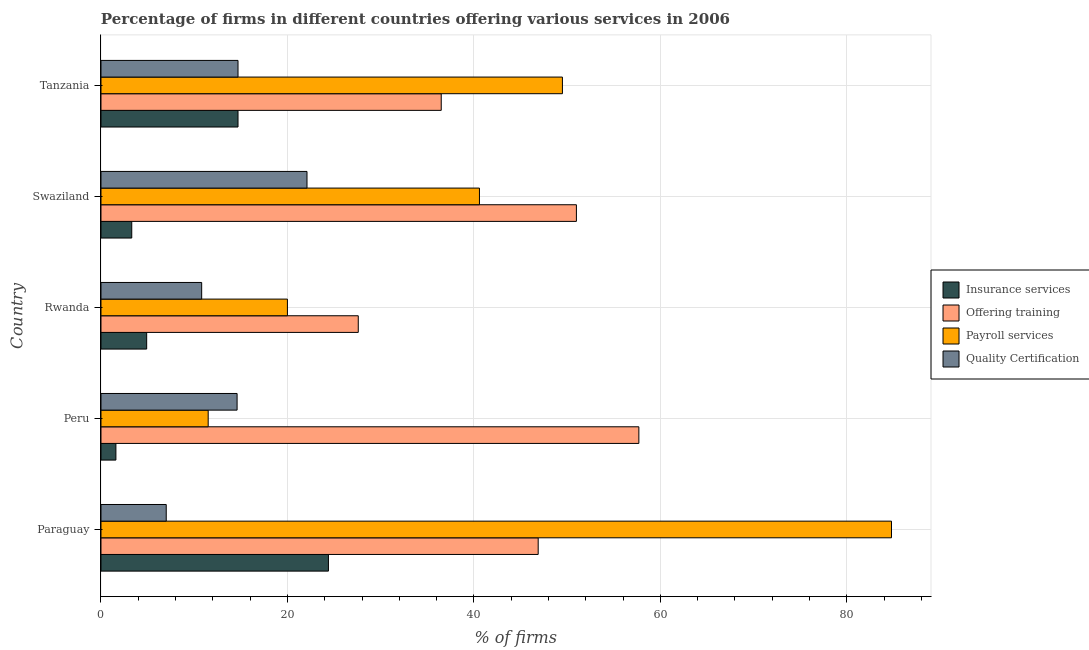How many different coloured bars are there?
Your answer should be compact. 4. Are the number of bars on each tick of the Y-axis equal?
Make the answer very short. Yes. How many bars are there on the 3rd tick from the top?
Give a very brief answer. 4. What is the label of the 3rd group of bars from the top?
Your response must be concise. Rwanda. In how many cases, is the number of bars for a given country not equal to the number of legend labels?
Make the answer very short. 0. What is the percentage of firms offering quality certification in Swaziland?
Make the answer very short. 22.1. Across all countries, what is the maximum percentage of firms offering quality certification?
Your response must be concise. 22.1. Across all countries, what is the minimum percentage of firms offering training?
Ensure brevity in your answer.  27.6. In which country was the percentage of firms offering quality certification maximum?
Provide a short and direct response. Swaziland. In which country was the percentage of firms offering training minimum?
Provide a short and direct response. Rwanda. What is the total percentage of firms offering payroll services in the graph?
Offer a very short reply. 206.4. What is the difference between the percentage of firms offering payroll services in Tanzania and the percentage of firms offering insurance services in Peru?
Offer a terse response. 47.9. What is the average percentage of firms offering training per country?
Provide a short and direct response. 43.94. What is the difference between the percentage of firms offering insurance services and percentage of firms offering payroll services in Tanzania?
Your answer should be very brief. -34.8. What is the ratio of the percentage of firms offering insurance services in Peru to that in Swaziland?
Your answer should be very brief. 0.48. What is the difference between the highest and the second highest percentage of firms offering payroll services?
Make the answer very short. 35.3. What is the difference between the highest and the lowest percentage of firms offering training?
Offer a terse response. 30.1. What does the 2nd bar from the top in Rwanda represents?
Make the answer very short. Payroll services. What does the 4th bar from the bottom in Rwanda represents?
Your answer should be compact. Quality Certification. Are all the bars in the graph horizontal?
Offer a terse response. Yes. How many countries are there in the graph?
Your answer should be very brief. 5. Are the values on the major ticks of X-axis written in scientific E-notation?
Offer a very short reply. No. Does the graph contain grids?
Offer a terse response. Yes. How many legend labels are there?
Make the answer very short. 4. What is the title of the graph?
Offer a terse response. Percentage of firms in different countries offering various services in 2006. What is the label or title of the X-axis?
Provide a succinct answer. % of firms. What is the label or title of the Y-axis?
Offer a terse response. Country. What is the % of firms of Insurance services in Paraguay?
Provide a succinct answer. 24.4. What is the % of firms of Offering training in Paraguay?
Keep it short and to the point. 46.9. What is the % of firms in Payroll services in Paraguay?
Provide a succinct answer. 84.8. What is the % of firms in Quality Certification in Paraguay?
Provide a succinct answer. 7. What is the % of firms of Offering training in Peru?
Provide a succinct answer. 57.7. What is the % of firms of Quality Certification in Peru?
Keep it short and to the point. 14.6. What is the % of firms in Offering training in Rwanda?
Offer a terse response. 27.6. What is the % of firms of Insurance services in Swaziland?
Your answer should be very brief. 3.3. What is the % of firms of Offering training in Swaziland?
Provide a succinct answer. 51. What is the % of firms of Payroll services in Swaziland?
Provide a short and direct response. 40.6. What is the % of firms of Quality Certification in Swaziland?
Make the answer very short. 22.1. What is the % of firms of Offering training in Tanzania?
Give a very brief answer. 36.5. What is the % of firms in Payroll services in Tanzania?
Your answer should be compact. 49.5. What is the % of firms in Quality Certification in Tanzania?
Keep it short and to the point. 14.7. Across all countries, what is the maximum % of firms of Insurance services?
Provide a short and direct response. 24.4. Across all countries, what is the maximum % of firms of Offering training?
Keep it short and to the point. 57.7. Across all countries, what is the maximum % of firms of Payroll services?
Your answer should be very brief. 84.8. Across all countries, what is the maximum % of firms of Quality Certification?
Your answer should be compact. 22.1. Across all countries, what is the minimum % of firms in Offering training?
Your answer should be compact. 27.6. Across all countries, what is the minimum % of firms in Payroll services?
Keep it short and to the point. 11.5. What is the total % of firms in Insurance services in the graph?
Offer a very short reply. 48.9. What is the total % of firms in Offering training in the graph?
Your answer should be very brief. 219.7. What is the total % of firms of Payroll services in the graph?
Provide a succinct answer. 206.4. What is the total % of firms of Quality Certification in the graph?
Your response must be concise. 69.2. What is the difference between the % of firms in Insurance services in Paraguay and that in Peru?
Provide a short and direct response. 22.8. What is the difference between the % of firms of Payroll services in Paraguay and that in Peru?
Keep it short and to the point. 73.3. What is the difference between the % of firms of Insurance services in Paraguay and that in Rwanda?
Your response must be concise. 19.5. What is the difference between the % of firms in Offering training in Paraguay and that in Rwanda?
Make the answer very short. 19.3. What is the difference between the % of firms of Payroll services in Paraguay and that in Rwanda?
Offer a very short reply. 64.8. What is the difference between the % of firms of Quality Certification in Paraguay and that in Rwanda?
Provide a succinct answer. -3.8. What is the difference between the % of firms of Insurance services in Paraguay and that in Swaziland?
Offer a terse response. 21.1. What is the difference between the % of firms in Payroll services in Paraguay and that in Swaziland?
Give a very brief answer. 44.2. What is the difference between the % of firms in Quality Certification in Paraguay and that in Swaziland?
Offer a very short reply. -15.1. What is the difference between the % of firms of Insurance services in Paraguay and that in Tanzania?
Your response must be concise. 9.7. What is the difference between the % of firms in Payroll services in Paraguay and that in Tanzania?
Offer a terse response. 35.3. What is the difference between the % of firms in Insurance services in Peru and that in Rwanda?
Provide a succinct answer. -3.3. What is the difference between the % of firms in Offering training in Peru and that in Rwanda?
Your answer should be very brief. 30.1. What is the difference between the % of firms in Quality Certification in Peru and that in Rwanda?
Make the answer very short. 3.8. What is the difference between the % of firms in Payroll services in Peru and that in Swaziland?
Provide a succinct answer. -29.1. What is the difference between the % of firms of Quality Certification in Peru and that in Swaziland?
Provide a short and direct response. -7.5. What is the difference between the % of firms in Insurance services in Peru and that in Tanzania?
Offer a very short reply. -13.1. What is the difference between the % of firms of Offering training in Peru and that in Tanzania?
Provide a succinct answer. 21.2. What is the difference between the % of firms in Payroll services in Peru and that in Tanzania?
Make the answer very short. -38. What is the difference between the % of firms of Insurance services in Rwanda and that in Swaziland?
Ensure brevity in your answer.  1.6. What is the difference between the % of firms in Offering training in Rwanda and that in Swaziland?
Keep it short and to the point. -23.4. What is the difference between the % of firms in Payroll services in Rwanda and that in Swaziland?
Make the answer very short. -20.6. What is the difference between the % of firms of Payroll services in Rwanda and that in Tanzania?
Provide a succinct answer. -29.5. What is the difference between the % of firms in Insurance services in Paraguay and the % of firms in Offering training in Peru?
Your answer should be compact. -33.3. What is the difference between the % of firms in Insurance services in Paraguay and the % of firms in Payroll services in Peru?
Your answer should be very brief. 12.9. What is the difference between the % of firms in Insurance services in Paraguay and the % of firms in Quality Certification in Peru?
Keep it short and to the point. 9.8. What is the difference between the % of firms in Offering training in Paraguay and the % of firms in Payroll services in Peru?
Keep it short and to the point. 35.4. What is the difference between the % of firms of Offering training in Paraguay and the % of firms of Quality Certification in Peru?
Ensure brevity in your answer.  32.3. What is the difference between the % of firms of Payroll services in Paraguay and the % of firms of Quality Certification in Peru?
Your answer should be compact. 70.2. What is the difference between the % of firms of Insurance services in Paraguay and the % of firms of Payroll services in Rwanda?
Provide a short and direct response. 4.4. What is the difference between the % of firms of Insurance services in Paraguay and the % of firms of Quality Certification in Rwanda?
Your response must be concise. 13.6. What is the difference between the % of firms in Offering training in Paraguay and the % of firms in Payroll services in Rwanda?
Make the answer very short. 26.9. What is the difference between the % of firms of Offering training in Paraguay and the % of firms of Quality Certification in Rwanda?
Give a very brief answer. 36.1. What is the difference between the % of firms of Insurance services in Paraguay and the % of firms of Offering training in Swaziland?
Ensure brevity in your answer.  -26.6. What is the difference between the % of firms in Insurance services in Paraguay and the % of firms in Payroll services in Swaziland?
Make the answer very short. -16.2. What is the difference between the % of firms in Insurance services in Paraguay and the % of firms in Quality Certification in Swaziland?
Keep it short and to the point. 2.3. What is the difference between the % of firms of Offering training in Paraguay and the % of firms of Quality Certification in Swaziland?
Your answer should be compact. 24.8. What is the difference between the % of firms in Payroll services in Paraguay and the % of firms in Quality Certification in Swaziland?
Offer a terse response. 62.7. What is the difference between the % of firms of Insurance services in Paraguay and the % of firms of Payroll services in Tanzania?
Ensure brevity in your answer.  -25.1. What is the difference between the % of firms in Offering training in Paraguay and the % of firms in Payroll services in Tanzania?
Ensure brevity in your answer.  -2.6. What is the difference between the % of firms of Offering training in Paraguay and the % of firms of Quality Certification in Tanzania?
Ensure brevity in your answer.  32.2. What is the difference between the % of firms in Payroll services in Paraguay and the % of firms in Quality Certification in Tanzania?
Give a very brief answer. 70.1. What is the difference between the % of firms in Insurance services in Peru and the % of firms in Payroll services in Rwanda?
Offer a very short reply. -18.4. What is the difference between the % of firms in Insurance services in Peru and the % of firms in Quality Certification in Rwanda?
Provide a succinct answer. -9.2. What is the difference between the % of firms of Offering training in Peru and the % of firms of Payroll services in Rwanda?
Give a very brief answer. 37.7. What is the difference between the % of firms in Offering training in Peru and the % of firms in Quality Certification in Rwanda?
Your answer should be very brief. 46.9. What is the difference between the % of firms of Payroll services in Peru and the % of firms of Quality Certification in Rwanda?
Provide a short and direct response. 0.7. What is the difference between the % of firms in Insurance services in Peru and the % of firms in Offering training in Swaziland?
Ensure brevity in your answer.  -49.4. What is the difference between the % of firms in Insurance services in Peru and the % of firms in Payroll services in Swaziland?
Your response must be concise. -39. What is the difference between the % of firms in Insurance services in Peru and the % of firms in Quality Certification in Swaziland?
Give a very brief answer. -20.5. What is the difference between the % of firms of Offering training in Peru and the % of firms of Quality Certification in Swaziland?
Offer a very short reply. 35.6. What is the difference between the % of firms of Insurance services in Peru and the % of firms of Offering training in Tanzania?
Provide a succinct answer. -34.9. What is the difference between the % of firms in Insurance services in Peru and the % of firms in Payroll services in Tanzania?
Provide a succinct answer. -47.9. What is the difference between the % of firms of Offering training in Peru and the % of firms of Payroll services in Tanzania?
Provide a succinct answer. 8.2. What is the difference between the % of firms in Offering training in Peru and the % of firms in Quality Certification in Tanzania?
Provide a short and direct response. 43. What is the difference between the % of firms in Payroll services in Peru and the % of firms in Quality Certification in Tanzania?
Give a very brief answer. -3.2. What is the difference between the % of firms in Insurance services in Rwanda and the % of firms in Offering training in Swaziland?
Give a very brief answer. -46.1. What is the difference between the % of firms in Insurance services in Rwanda and the % of firms in Payroll services in Swaziland?
Your response must be concise. -35.7. What is the difference between the % of firms of Insurance services in Rwanda and the % of firms of Quality Certification in Swaziland?
Your response must be concise. -17.2. What is the difference between the % of firms in Offering training in Rwanda and the % of firms in Payroll services in Swaziland?
Provide a succinct answer. -13. What is the difference between the % of firms in Payroll services in Rwanda and the % of firms in Quality Certification in Swaziland?
Provide a short and direct response. -2.1. What is the difference between the % of firms of Insurance services in Rwanda and the % of firms of Offering training in Tanzania?
Provide a short and direct response. -31.6. What is the difference between the % of firms of Insurance services in Rwanda and the % of firms of Payroll services in Tanzania?
Offer a terse response. -44.6. What is the difference between the % of firms in Offering training in Rwanda and the % of firms in Payroll services in Tanzania?
Provide a short and direct response. -21.9. What is the difference between the % of firms of Payroll services in Rwanda and the % of firms of Quality Certification in Tanzania?
Provide a short and direct response. 5.3. What is the difference between the % of firms of Insurance services in Swaziland and the % of firms of Offering training in Tanzania?
Offer a terse response. -33.2. What is the difference between the % of firms of Insurance services in Swaziland and the % of firms of Payroll services in Tanzania?
Keep it short and to the point. -46.2. What is the difference between the % of firms of Insurance services in Swaziland and the % of firms of Quality Certification in Tanzania?
Keep it short and to the point. -11.4. What is the difference between the % of firms of Offering training in Swaziland and the % of firms of Quality Certification in Tanzania?
Your response must be concise. 36.3. What is the difference between the % of firms in Payroll services in Swaziland and the % of firms in Quality Certification in Tanzania?
Offer a very short reply. 25.9. What is the average % of firms in Insurance services per country?
Offer a very short reply. 9.78. What is the average % of firms of Offering training per country?
Your answer should be very brief. 43.94. What is the average % of firms of Payroll services per country?
Your answer should be very brief. 41.28. What is the average % of firms in Quality Certification per country?
Keep it short and to the point. 13.84. What is the difference between the % of firms of Insurance services and % of firms of Offering training in Paraguay?
Offer a terse response. -22.5. What is the difference between the % of firms of Insurance services and % of firms of Payroll services in Paraguay?
Offer a very short reply. -60.4. What is the difference between the % of firms of Offering training and % of firms of Payroll services in Paraguay?
Your answer should be compact. -37.9. What is the difference between the % of firms in Offering training and % of firms in Quality Certification in Paraguay?
Provide a succinct answer. 39.9. What is the difference between the % of firms of Payroll services and % of firms of Quality Certification in Paraguay?
Offer a very short reply. 77.8. What is the difference between the % of firms in Insurance services and % of firms in Offering training in Peru?
Give a very brief answer. -56.1. What is the difference between the % of firms of Insurance services and % of firms of Payroll services in Peru?
Your answer should be very brief. -9.9. What is the difference between the % of firms in Insurance services and % of firms in Quality Certification in Peru?
Give a very brief answer. -13. What is the difference between the % of firms of Offering training and % of firms of Payroll services in Peru?
Make the answer very short. 46.2. What is the difference between the % of firms in Offering training and % of firms in Quality Certification in Peru?
Offer a very short reply. 43.1. What is the difference between the % of firms in Payroll services and % of firms in Quality Certification in Peru?
Your answer should be compact. -3.1. What is the difference between the % of firms in Insurance services and % of firms in Offering training in Rwanda?
Your answer should be very brief. -22.7. What is the difference between the % of firms of Insurance services and % of firms of Payroll services in Rwanda?
Provide a short and direct response. -15.1. What is the difference between the % of firms in Offering training and % of firms in Payroll services in Rwanda?
Give a very brief answer. 7.6. What is the difference between the % of firms of Offering training and % of firms of Quality Certification in Rwanda?
Provide a succinct answer. 16.8. What is the difference between the % of firms of Payroll services and % of firms of Quality Certification in Rwanda?
Provide a succinct answer. 9.2. What is the difference between the % of firms of Insurance services and % of firms of Offering training in Swaziland?
Your answer should be very brief. -47.7. What is the difference between the % of firms in Insurance services and % of firms in Payroll services in Swaziland?
Offer a very short reply. -37.3. What is the difference between the % of firms in Insurance services and % of firms in Quality Certification in Swaziland?
Offer a terse response. -18.8. What is the difference between the % of firms in Offering training and % of firms in Payroll services in Swaziland?
Give a very brief answer. 10.4. What is the difference between the % of firms in Offering training and % of firms in Quality Certification in Swaziland?
Offer a very short reply. 28.9. What is the difference between the % of firms in Payroll services and % of firms in Quality Certification in Swaziland?
Give a very brief answer. 18.5. What is the difference between the % of firms in Insurance services and % of firms in Offering training in Tanzania?
Your response must be concise. -21.8. What is the difference between the % of firms in Insurance services and % of firms in Payroll services in Tanzania?
Ensure brevity in your answer.  -34.8. What is the difference between the % of firms of Insurance services and % of firms of Quality Certification in Tanzania?
Provide a short and direct response. 0. What is the difference between the % of firms in Offering training and % of firms in Quality Certification in Tanzania?
Keep it short and to the point. 21.8. What is the difference between the % of firms of Payroll services and % of firms of Quality Certification in Tanzania?
Provide a succinct answer. 34.8. What is the ratio of the % of firms in Insurance services in Paraguay to that in Peru?
Keep it short and to the point. 15.25. What is the ratio of the % of firms of Offering training in Paraguay to that in Peru?
Make the answer very short. 0.81. What is the ratio of the % of firms of Payroll services in Paraguay to that in Peru?
Your response must be concise. 7.37. What is the ratio of the % of firms of Quality Certification in Paraguay to that in Peru?
Offer a very short reply. 0.48. What is the ratio of the % of firms in Insurance services in Paraguay to that in Rwanda?
Give a very brief answer. 4.98. What is the ratio of the % of firms in Offering training in Paraguay to that in Rwanda?
Ensure brevity in your answer.  1.7. What is the ratio of the % of firms in Payroll services in Paraguay to that in Rwanda?
Provide a short and direct response. 4.24. What is the ratio of the % of firms in Quality Certification in Paraguay to that in Rwanda?
Offer a very short reply. 0.65. What is the ratio of the % of firms in Insurance services in Paraguay to that in Swaziland?
Offer a terse response. 7.39. What is the ratio of the % of firms of Offering training in Paraguay to that in Swaziland?
Your response must be concise. 0.92. What is the ratio of the % of firms of Payroll services in Paraguay to that in Swaziland?
Give a very brief answer. 2.09. What is the ratio of the % of firms in Quality Certification in Paraguay to that in Swaziland?
Your response must be concise. 0.32. What is the ratio of the % of firms of Insurance services in Paraguay to that in Tanzania?
Provide a succinct answer. 1.66. What is the ratio of the % of firms of Offering training in Paraguay to that in Tanzania?
Provide a short and direct response. 1.28. What is the ratio of the % of firms in Payroll services in Paraguay to that in Tanzania?
Make the answer very short. 1.71. What is the ratio of the % of firms in Quality Certification in Paraguay to that in Tanzania?
Ensure brevity in your answer.  0.48. What is the ratio of the % of firms of Insurance services in Peru to that in Rwanda?
Offer a terse response. 0.33. What is the ratio of the % of firms of Offering training in Peru to that in Rwanda?
Your answer should be very brief. 2.09. What is the ratio of the % of firms in Payroll services in Peru to that in Rwanda?
Offer a very short reply. 0.57. What is the ratio of the % of firms of Quality Certification in Peru to that in Rwanda?
Give a very brief answer. 1.35. What is the ratio of the % of firms in Insurance services in Peru to that in Swaziland?
Ensure brevity in your answer.  0.48. What is the ratio of the % of firms of Offering training in Peru to that in Swaziland?
Offer a terse response. 1.13. What is the ratio of the % of firms of Payroll services in Peru to that in Swaziland?
Your answer should be compact. 0.28. What is the ratio of the % of firms in Quality Certification in Peru to that in Swaziland?
Your response must be concise. 0.66. What is the ratio of the % of firms in Insurance services in Peru to that in Tanzania?
Give a very brief answer. 0.11. What is the ratio of the % of firms in Offering training in Peru to that in Tanzania?
Offer a very short reply. 1.58. What is the ratio of the % of firms in Payroll services in Peru to that in Tanzania?
Your response must be concise. 0.23. What is the ratio of the % of firms of Insurance services in Rwanda to that in Swaziland?
Make the answer very short. 1.48. What is the ratio of the % of firms in Offering training in Rwanda to that in Swaziland?
Give a very brief answer. 0.54. What is the ratio of the % of firms in Payroll services in Rwanda to that in Swaziland?
Your response must be concise. 0.49. What is the ratio of the % of firms of Quality Certification in Rwanda to that in Swaziland?
Your answer should be compact. 0.49. What is the ratio of the % of firms of Insurance services in Rwanda to that in Tanzania?
Offer a terse response. 0.33. What is the ratio of the % of firms in Offering training in Rwanda to that in Tanzania?
Provide a short and direct response. 0.76. What is the ratio of the % of firms in Payroll services in Rwanda to that in Tanzania?
Provide a short and direct response. 0.4. What is the ratio of the % of firms in Quality Certification in Rwanda to that in Tanzania?
Keep it short and to the point. 0.73. What is the ratio of the % of firms in Insurance services in Swaziland to that in Tanzania?
Offer a very short reply. 0.22. What is the ratio of the % of firms in Offering training in Swaziland to that in Tanzania?
Keep it short and to the point. 1.4. What is the ratio of the % of firms in Payroll services in Swaziland to that in Tanzania?
Provide a short and direct response. 0.82. What is the ratio of the % of firms in Quality Certification in Swaziland to that in Tanzania?
Provide a short and direct response. 1.5. What is the difference between the highest and the second highest % of firms in Offering training?
Give a very brief answer. 6.7. What is the difference between the highest and the second highest % of firms in Payroll services?
Make the answer very short. 35.3. What is the difference between the highest and the lowest % of firms in Insurance services?
Make the answer very short. 22.8. What is the difference between the highest and the lowest % of firms in Offering training?
Provide a succinct answer. 30.1. What is the difference between the highest and the lowest % of firms in Payroll services?
Your answer should be compact. 73.3. What is the difference between the highest and the lowest % of firms in Quality Certification?
Provide a short and direct response. 15.1. 